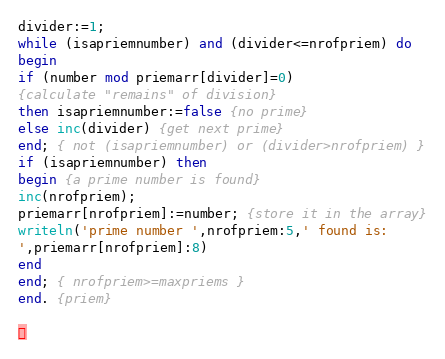Convert code to text. <code><loc_0><loc_0><loc_500><loc_500><_Pascal_>divider:=1;
while (isapriemnumber) and (divider<=nrofpriem) do
begin
if (number mod priemarr[divider]=0)
{calculate "remains" of division}
then isapriemnumber:=false {no prime}
else inc(divider) {get next prime}
end; { not (isapriemnumber) or (divider>nrofpriem) }
if (isapriemnumber) then
begin {a prime number is found}
inc(nrofpriem);
priemarr[nrofpriem]:=number; {store it in the array}
writeln('prime number ',nrofpriem:5,' found is:
',priemarr[nrofpriem]:8)
end
end; { nrofpriem>=maxpriems }
end. {priem}

</code> 